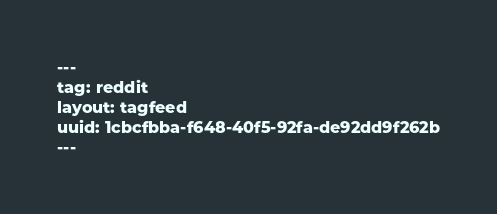Convert code to text. <code><loc_0><loc_0><loc_500><loc_500><_XML_>---
tag: reddit
layout: tagfeed
uuid: 1cbcfbba-f648-40f5-92fa-de92dd9f262b
---
</code> 